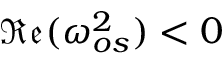<formula> <loc_0><loc_0><loc_500><loc_500>\mathfrak { R e } ( \omega _ { o s } ^ { 2 } ) < 0</formula> 